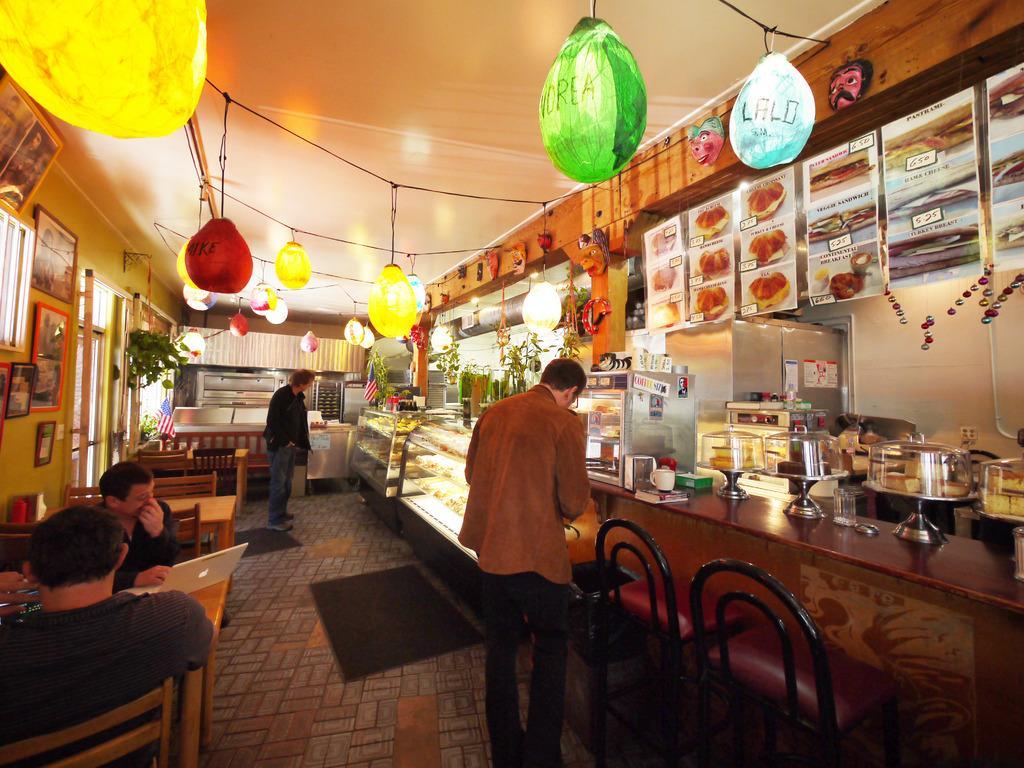Can you describe this image briefly? In this image I can see few people sitting on the chairs. I can see laptop,and some objects on the table. I can see a few stand,cakes,cups and some objects on the table. Top I can see colorful balloons. The frames are attached to the wall. I can see a flag,wall and windows. 